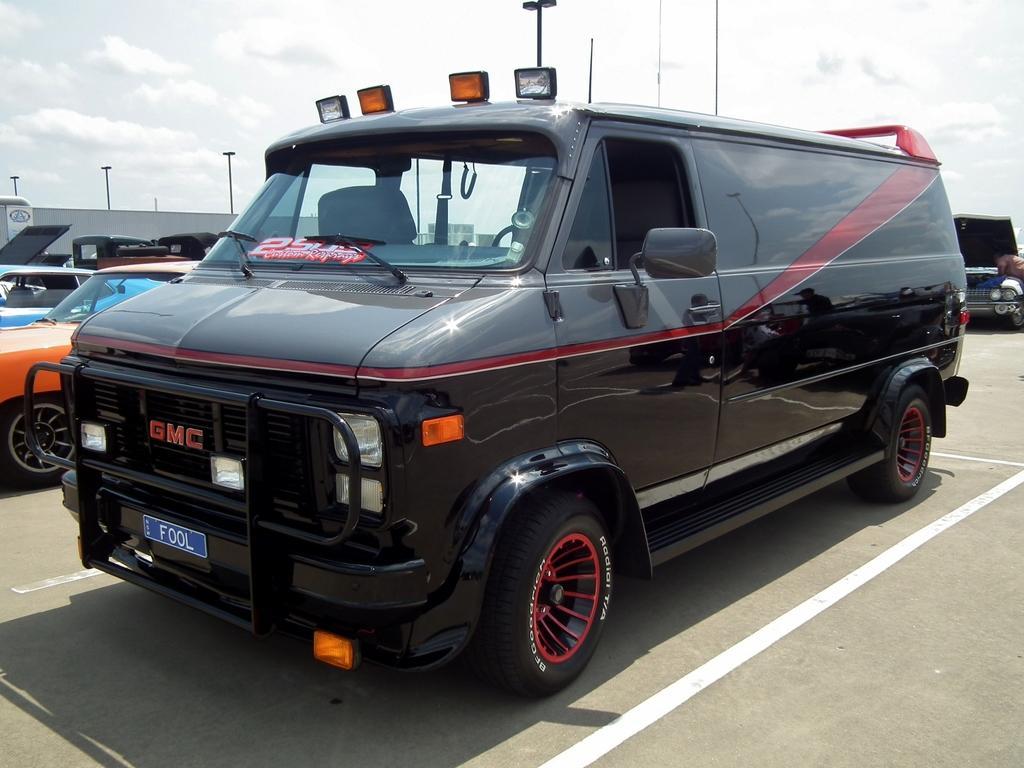In one or two sentences, can you explain what this image depicts? In this image we can see many vehicles. We can see the clouds in the sky. There is a shed at the left side of the image. We can see the road safety marking on the road. 